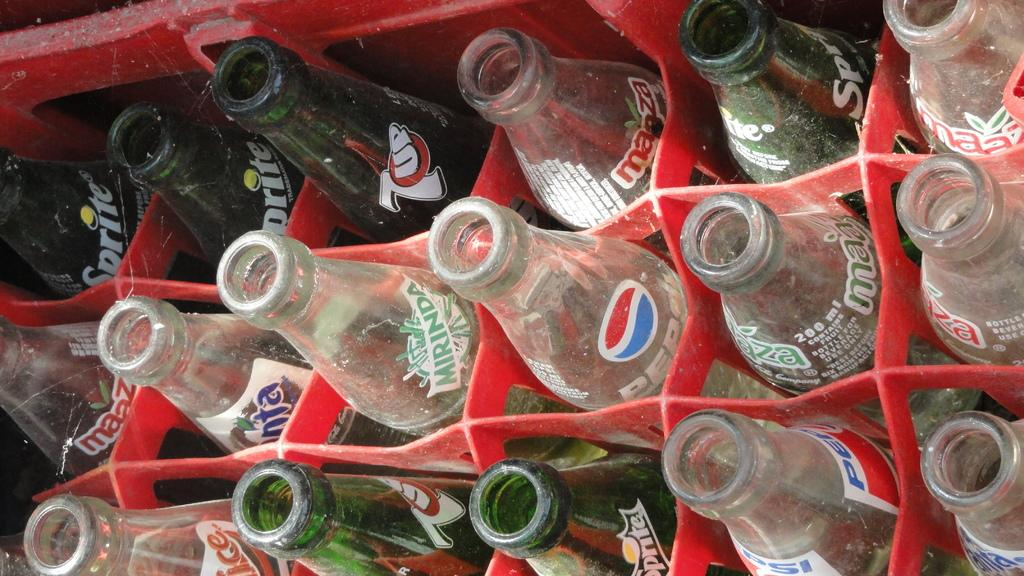What objects can be seen in the image? There are bottles in the image. How are the bottles arranged or positioned? The bottles are on a tray. Where is the playground located in the image? There is no playground present in the image; it only features bottles on a tray. What is the wind doing to the bottles in the image? The image does not show any wind or blowing action, so we cannot determine what the wind is doing to the bottles. 